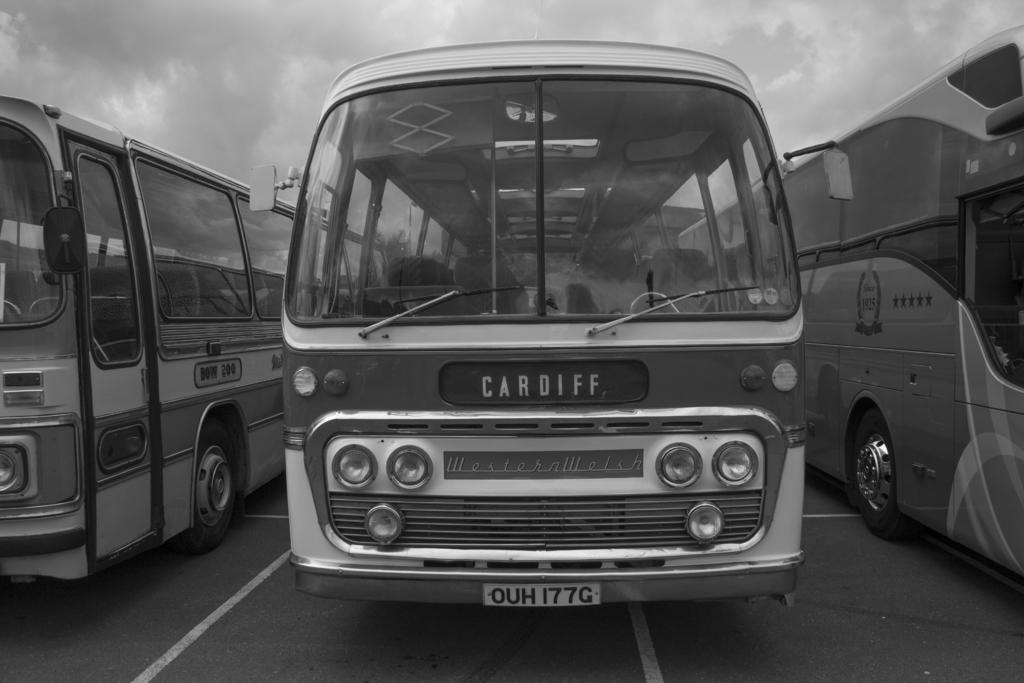<image>
Relay a brief, clear account of the picture shown. An old bus with License Plate: "OUH 177G" destined for Cardiff. 